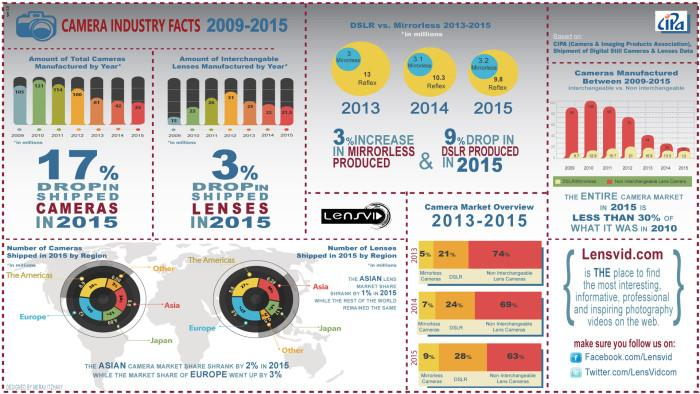Highlight a few significant elements in this photo. In 2015, there was a 3% decrease in the number of shipped lenses compared to the previous year. In 2015, there was a 17% decrease in the number of cameras that were shipped. 